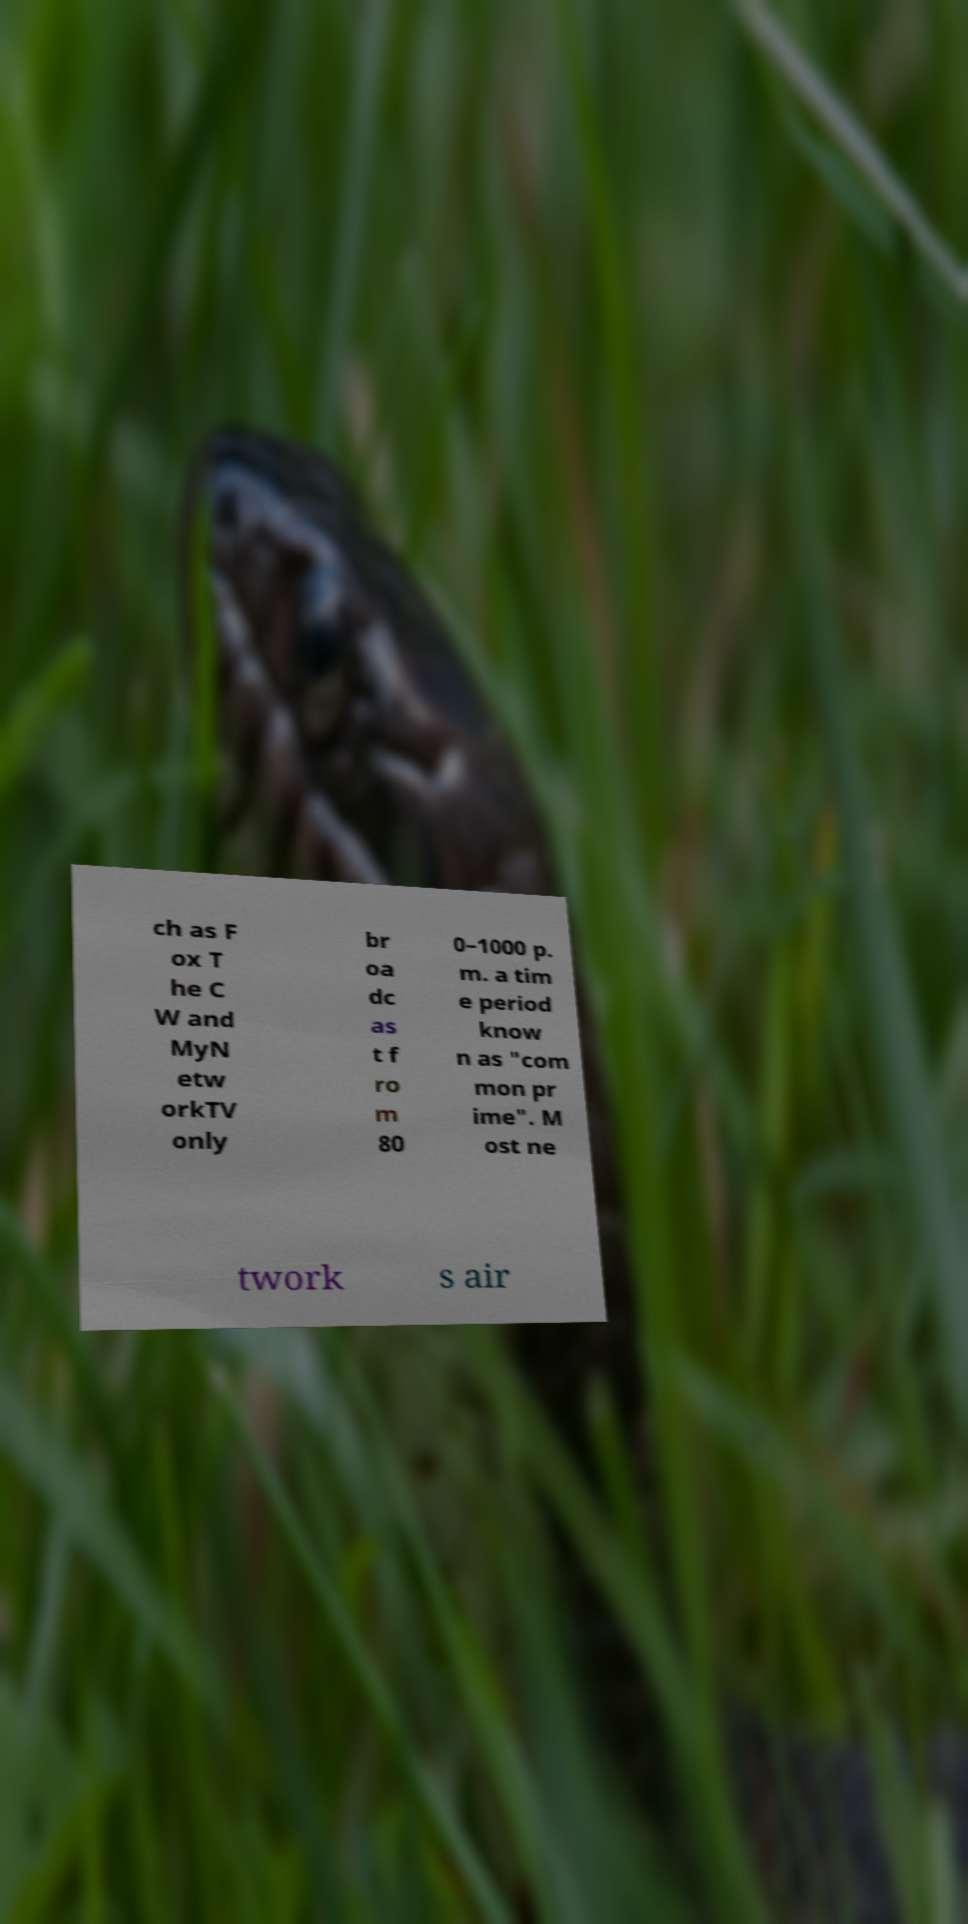What messages or text are displayed in this image? I need them in a readable, typed format. ch as F ox T he C W and MyN etw orkTV only br oa dc as t f ro m 80 0–1000 p. m. a tim e period know n as "com mon pr ime". M ost ne twork s air 